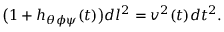<formula> <loc_0><loc_0><loc_500><loc_500>\left ( 1 + h _ { \theta \phi \psi } ( t ) \right ) d l ^ { 2 } = v ^ { 2 } ( t ) d t ^ { 2 } .</formula> 